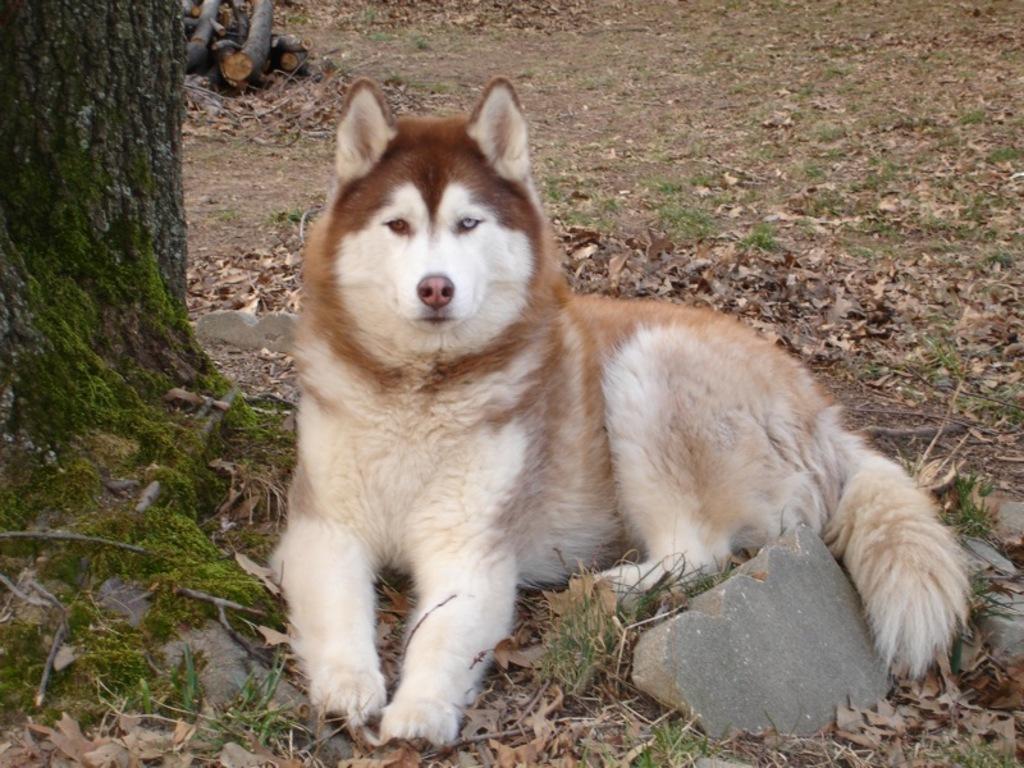In one or two sentences, can you explain what this image depicts? In this image I can see a dog which is in cream and brown color. Background I can see a trunk. 